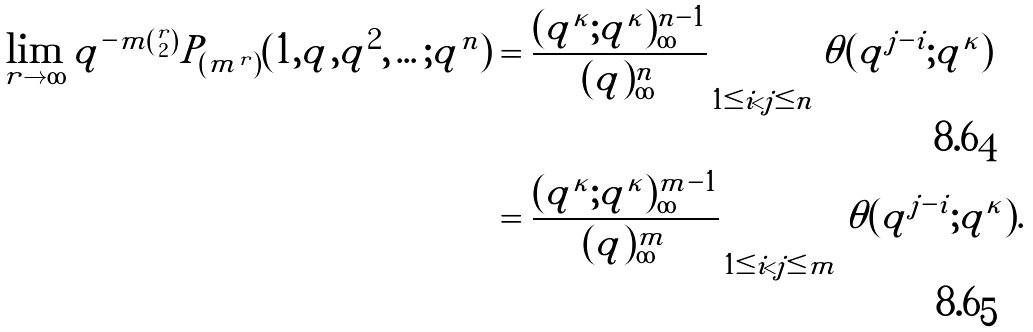Convert formula to latex. <formula><loc_0><loc_0><loc_500><loc_500>\lim _ { r \to \infty } q ^ { - m \binom { r } { 2 } } P _ { ( m ^ { r } ) } ( 1 , q , q ^ { 2 } , \dots ; q ^ { n } ) & = \frac { ( q ^ { \kappa } ; q ^ { \kappa } ) _ { \infty } ^ { n - 1 } } { ( q ) _ { \infty } ^ { n } } \prod _ { 1 \leq i < j \leq n } \theta ( q ^ { j - i } ; q ^ { \kappa } ) \\ & = \frac { ( q ^ { \kappa } ; q ^ { \kappa } ) _ { \infty } ^ { m - 1 } } { ( q ) _ { \infty } ^ { m } } \prod _ { 1 \leq i < j \leq m } \theta ( q ^ { j - i } ; q ^ { \kappa } ) .</formula> 